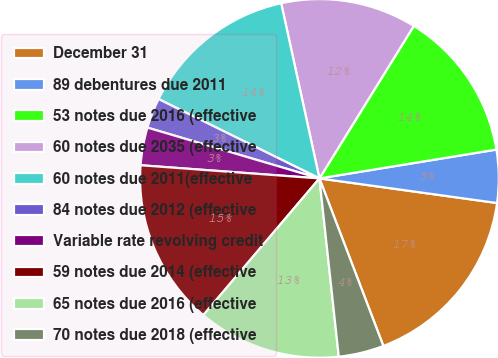Convert chart to OTSL. <chart><loc_0><loc_0><loc_500><loc_500><pie_chart><fcel>December 31<fcel>89 debentures due 2011<fcel>53 notes due 2016 (effective<fcel>60 notes due 2035 (effective<fcel>60 notes due 2011(effective<fcel>84 notes due 2012 (effective<fcel>Variable rate revolving credit<fcel>59 notes due 2014 (effective<fcel>65 notes due 2016 (effective<fcel>70 notes due 2018 (effective<nl><fcel>17.0%<fcel>4.76%<fcel>13.6%<fcel>12.24%<fcel>14.28%<fcel>2.72%<fcel>3.4%<fcel>14.96%<fcel>12.92%<fcel>4.08%<nl></chart> 